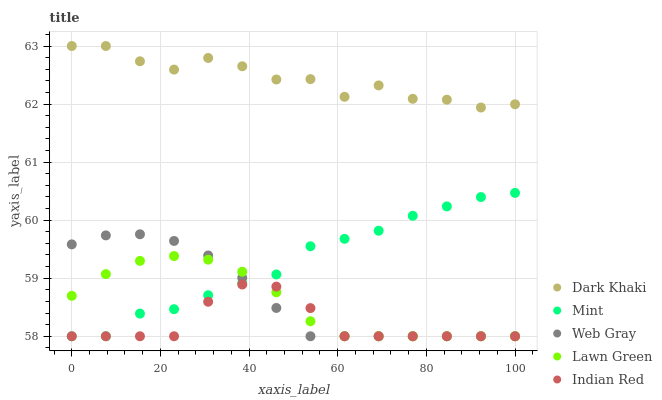Does Indian Red have the minimum area under the curve?
Answer yes or no. Yes. Does Dark Khaki have the maximum area under the curve?
Answer yes or no. Yes. Does Lawn Green have the minimum area under the curve?
Answer yes or no. No. Does Lawn Green have the maximum area under the curve?
Answer yes or no. No. Is Web Gray the smoothest?
Answer yes or no. Yes. Is Dark Khaki the roughest?
Answer yes or no. Yes. Is Lawn Green the smoothest?
Answer yes or no. No. Is Lawn Green the roughest?
Answer yes or no. No. Does Lawn Green have the lowest value?
Answer yes or no. Yes. Does Dark Khaki have the highest value?
Answer yes or no. Yes. Does Lawn Green have the highest value?
Answer yes or no. No. Is Mint less than Dark Khaki?
Answer yes or no. Yes. Is Dark Khaki greater than Mint?
Answer yes or no. Yes. Does Mint intersect Lawn Green?
Answer yes or no. Yes. Is Mint less than Lawn Green?
Answer yes or no. No. Is Mint greater than Lawn Green?
Answer yes or no. No. Does Mint intersect Dark Khaki?
Answer yes or no. No. 